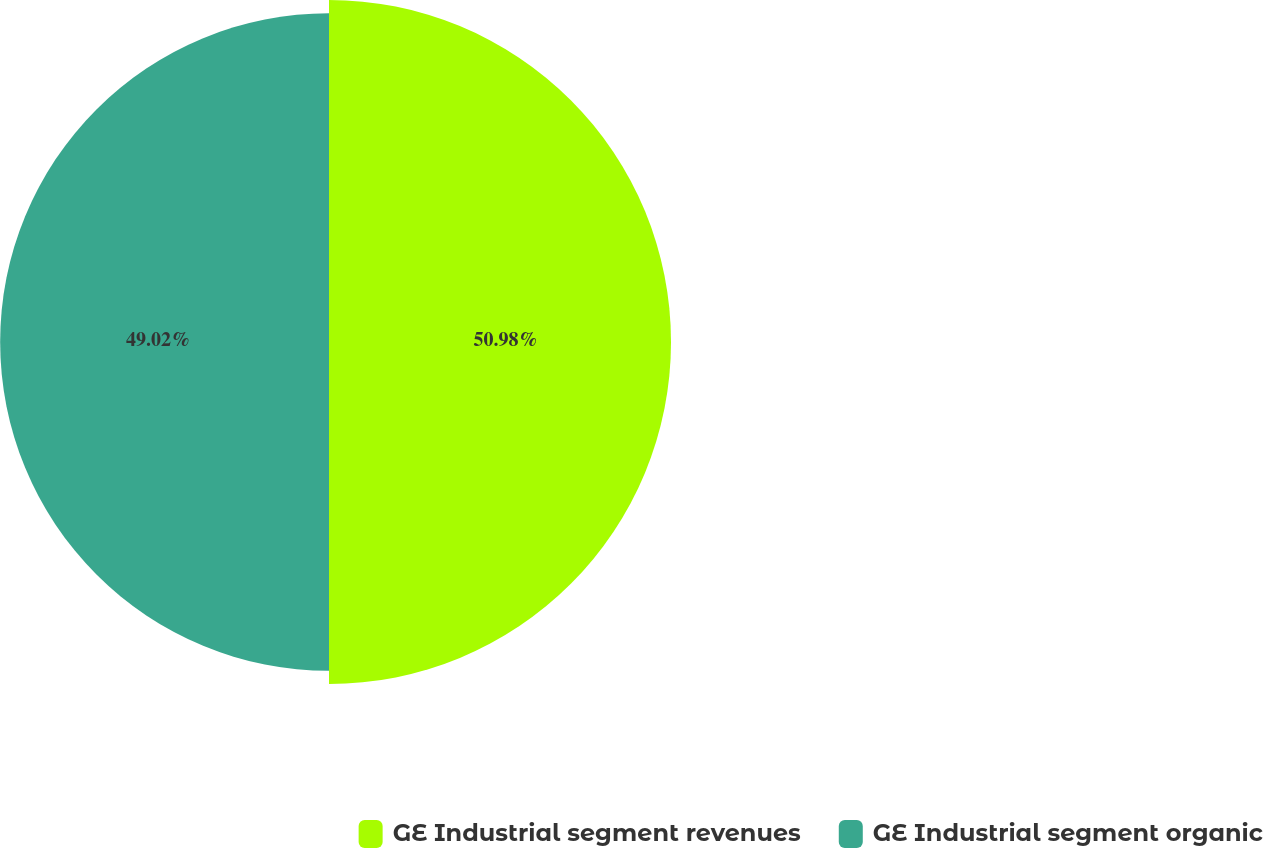Convert chart to OTSL. <chart><loc_0><loc_0><loc_500><loc_500><pie_chart><fcel>GE Industrial segment revenues<fcel>GE Industrial segment organic<nl><fcel>50.98%<fcel>49.02%<nl></chart> 